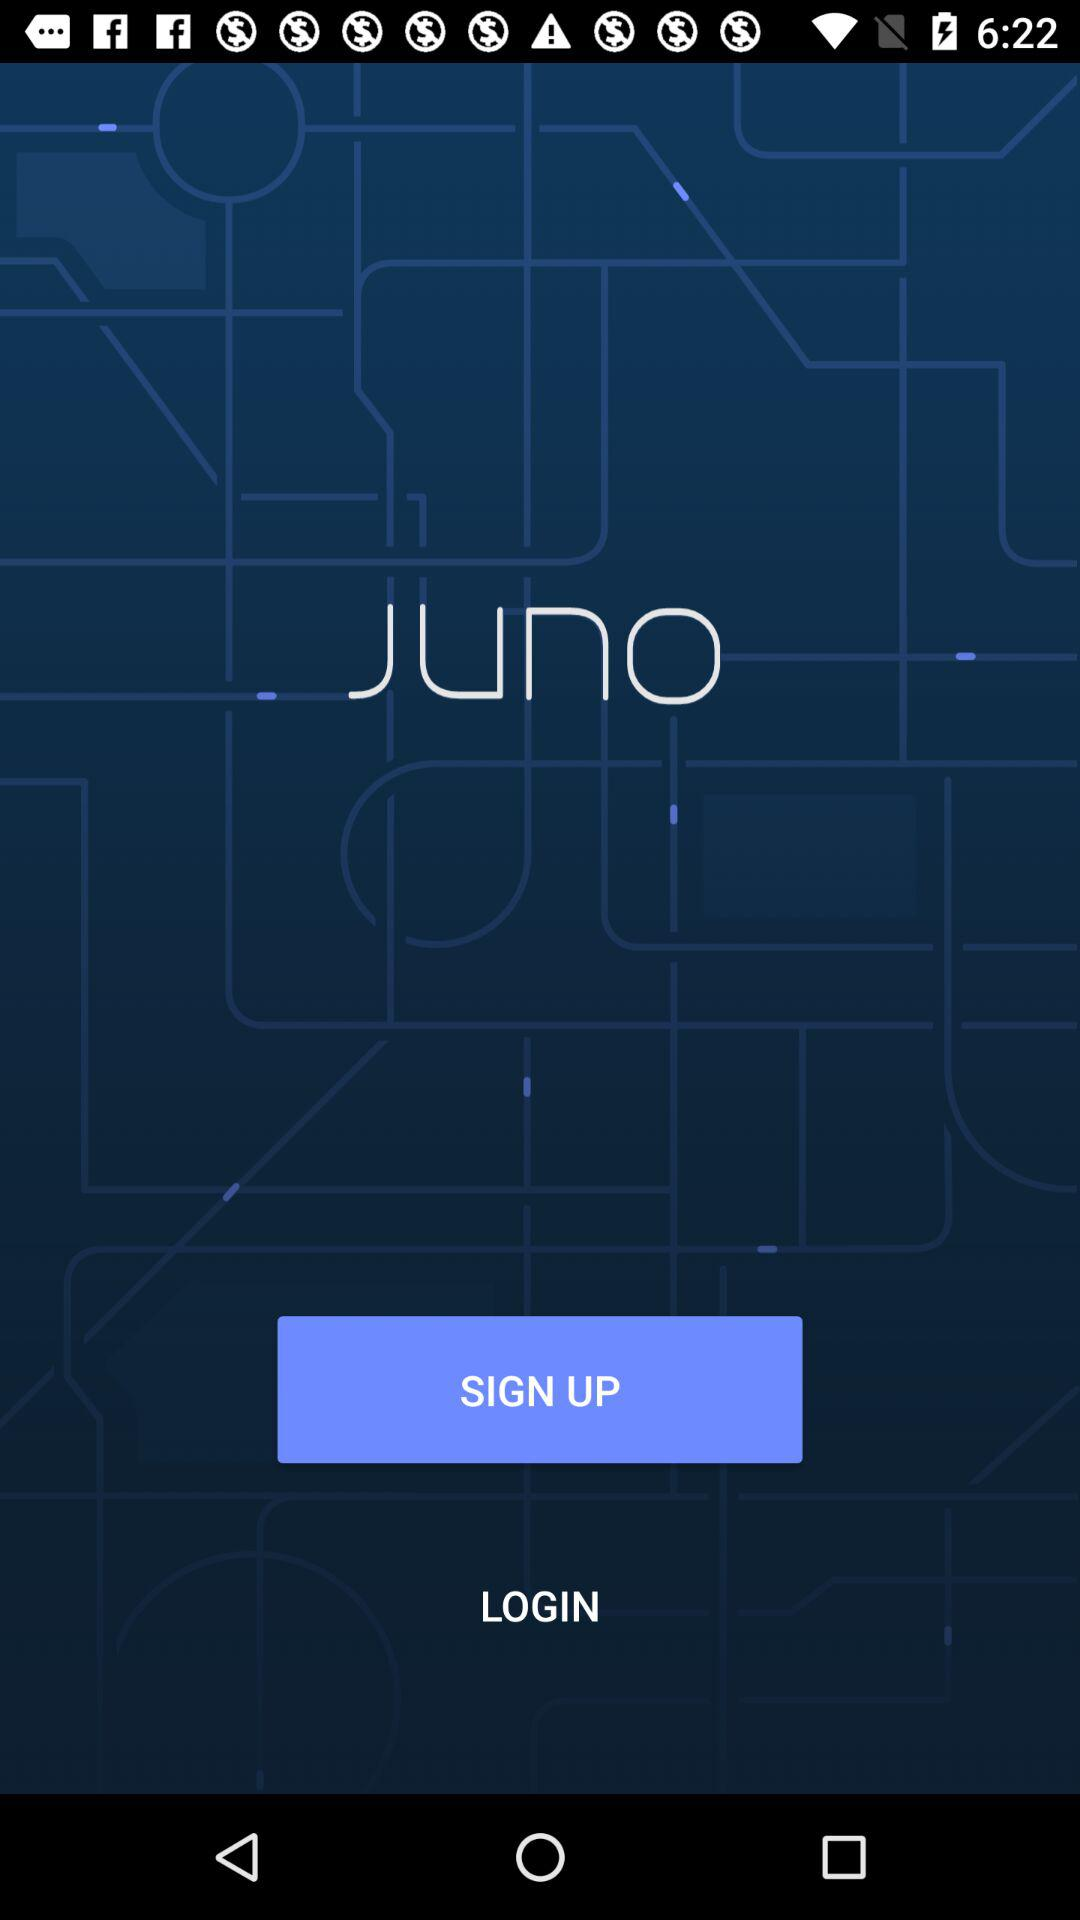What is the name of the application? The name of the application is "Juno". 